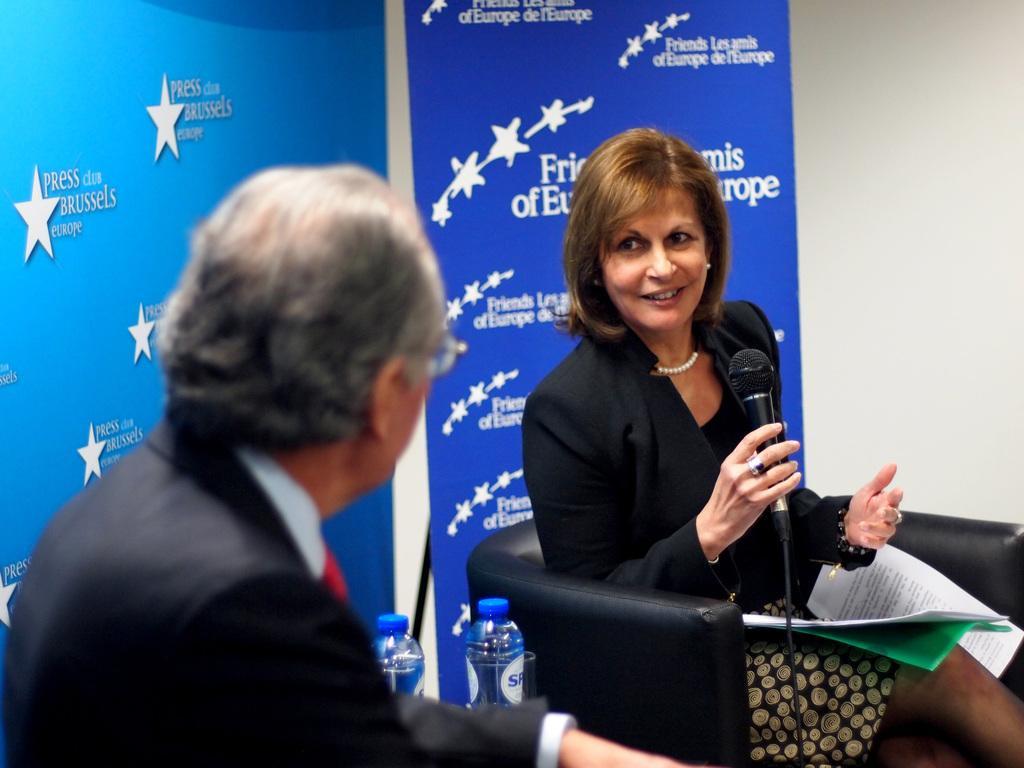Describe this image in one or two sentences. In this image there is a woman who is sitting in the chair by holding the mic with her hand. In front of her there is a file on which there are papers. On the left side there is a man. There are two bottles in between them. In the background there are banners. 